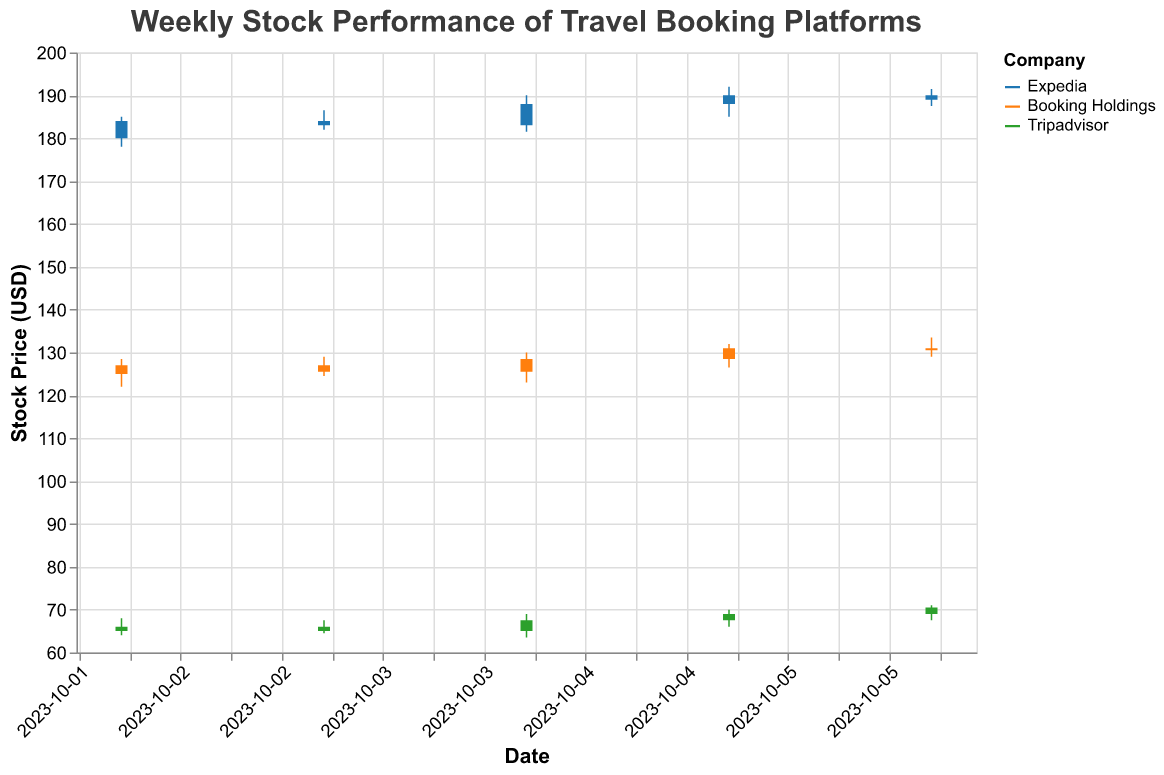What is the title of the chart? The title is typically displayed at the top of the chart. In this case, it is "Weekly Stock Performance of Travel Booking Platforms".
Answer: Weekly Stock Performance of Travel Booking Platforms Which travel booking platform had the highest closing stock price on October 6, 2023? By examining the closing prices on October 6 for each company, we see Expedia closed at $189.00, Booking Holdings at $130.50, and Tripadvisor at $70.50. The highest closing price among these is Expedia.
Answer: Expedia How did Tripadvisor’s stock price change between its open price and its closing price on October 4, 2023? On October 4, Tripadvisor's stock opened at $65.00 and closed at $67.50. The change in stock price is calculated by subtracting the opening price from the closing price: $67.50 - $65.00 = $2.50.
Answer: $2.50 Which company had the highest trading volume on October 5, 2023? The trading volumes on October 5 are listed for each company: Expedia (1,400,000), Booking Holdings (1,100,000), and Tripadvisor (850,000). Expedia had the highest trading volume.
Answer: Expedia On which date did Expedia’s stock close at the highest price during the week? For Expedia, the closing prices are: October 2 ($184.00), October 3 ($183.00), October 4 ($188.00), October 5 ($190.00), October 6 ($189.00). The highest closing price was on October 5.
Answer: October 5 What is the average closing stock price for Booking Holdings for the week? The closing prices for Booking Holdings over the week are: October 2 ($127.00), October 3 ($125.50), October 4 ($128.50), October 5 ($131.00), October 6 ($130.50). The average is calculated as (127.00 + 125.50 + 128.50 + 131.00 + 130.50) / 5 = 128.90.
Answer: 128.90 Which company had the most significant drop in closing stock price on any single day within the week? By comparing the daily changes in closing prices, we see Expedia went from $184.00 to $183.00 on October 3, a drop of $1.00; Booking Holdings had the biggest drop of $1.50 on October 3 (from $127.00 to $125.50), and Tripadvisor dropped $1.00 on October 3 (from $66.00 to $65.00). Thus, Booking Holdings had the most significant drop.
Answer: Booking Holdings Which company showed an upward trend throughout the week without any day's closing price being lower than the previous day's closing price? By observing the daily closing prices: Expedia had decreases on October 3; Booking Holdings also saw decreases; only Tripadvisor's closing prices ($66.00, $65.00, $67.50, $69.00, $70.50) show an overall upward trend without any day’s closing price being lower than the previous day.
Answer: Tripadvisor 